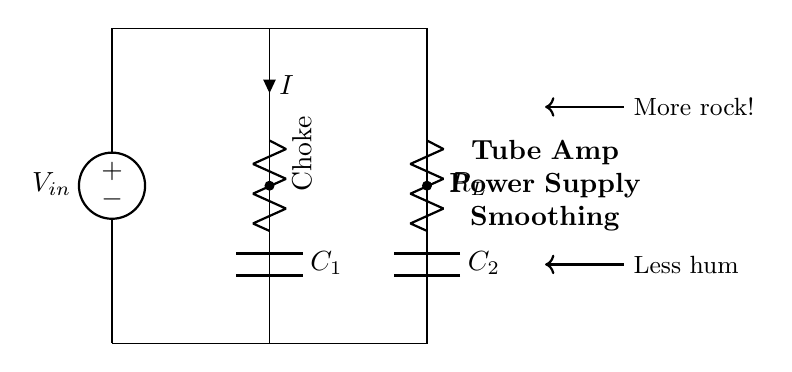What type of components are used in this circuit? The circuit includes a voltage source, two resistors, and two capacitors. These components are essential for power supply smoothing in tube amplifiers.
Answer: voltage source, resistors, capacitors What is the purpose of the choke in this circuit? The choke is used to limit the AC current flowing into the circuit while allowing DC current to pass, thereby contributing to reducing hum.
Answer: reduce hum How many capacitors are in this circuit? There are two capacitors (C1 and C2) in the circuit, which help in smoothing the voltage output.
Answer: two Which component is responsible for filtering in this circuit? The capacitors (C1 and C2) are responsible for filtering by charging and discharging to smooth out the voltage.
Answer: capacitors What is the effect of decreasing the resistance of R_L? Decreasing the resistance of R_L would increase the current flowing through the circuit, potentially leading to higher power output from the amplifier but may also cause more ripple voltage.
Answer: increase current What happens to voltage ripple when the capacitance is increased? Increasing the capacitance will lower the voltage ripple, as larger capacitors can store more charge, leading to smoother output voltage.
Answer: lower voltage ripple What feature of this circuit helps achieve "more rock"? The configuration with less hum and smoother voltage output facilitates better signal integrity in tube amplifiers, leading to a more desirable sound quality, hence achieving "more rock."
Answer: smoother voltage output 